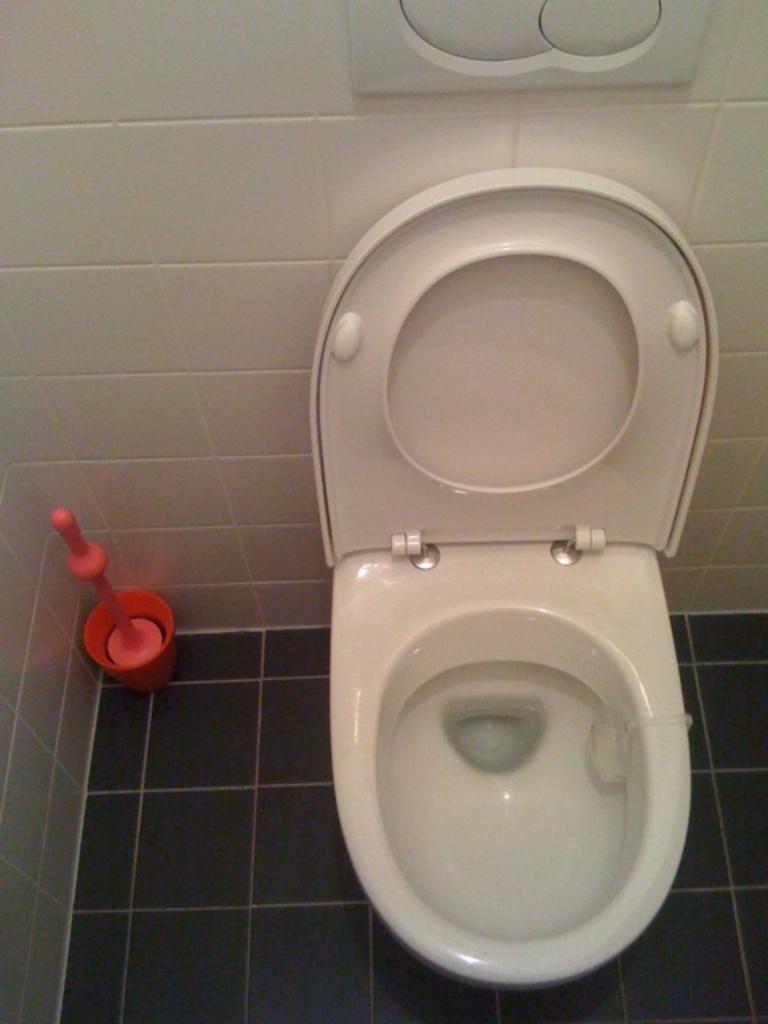Could you give a brief overview of what you see in this image? As we can see in the image there are white color tiles and western toilet. 